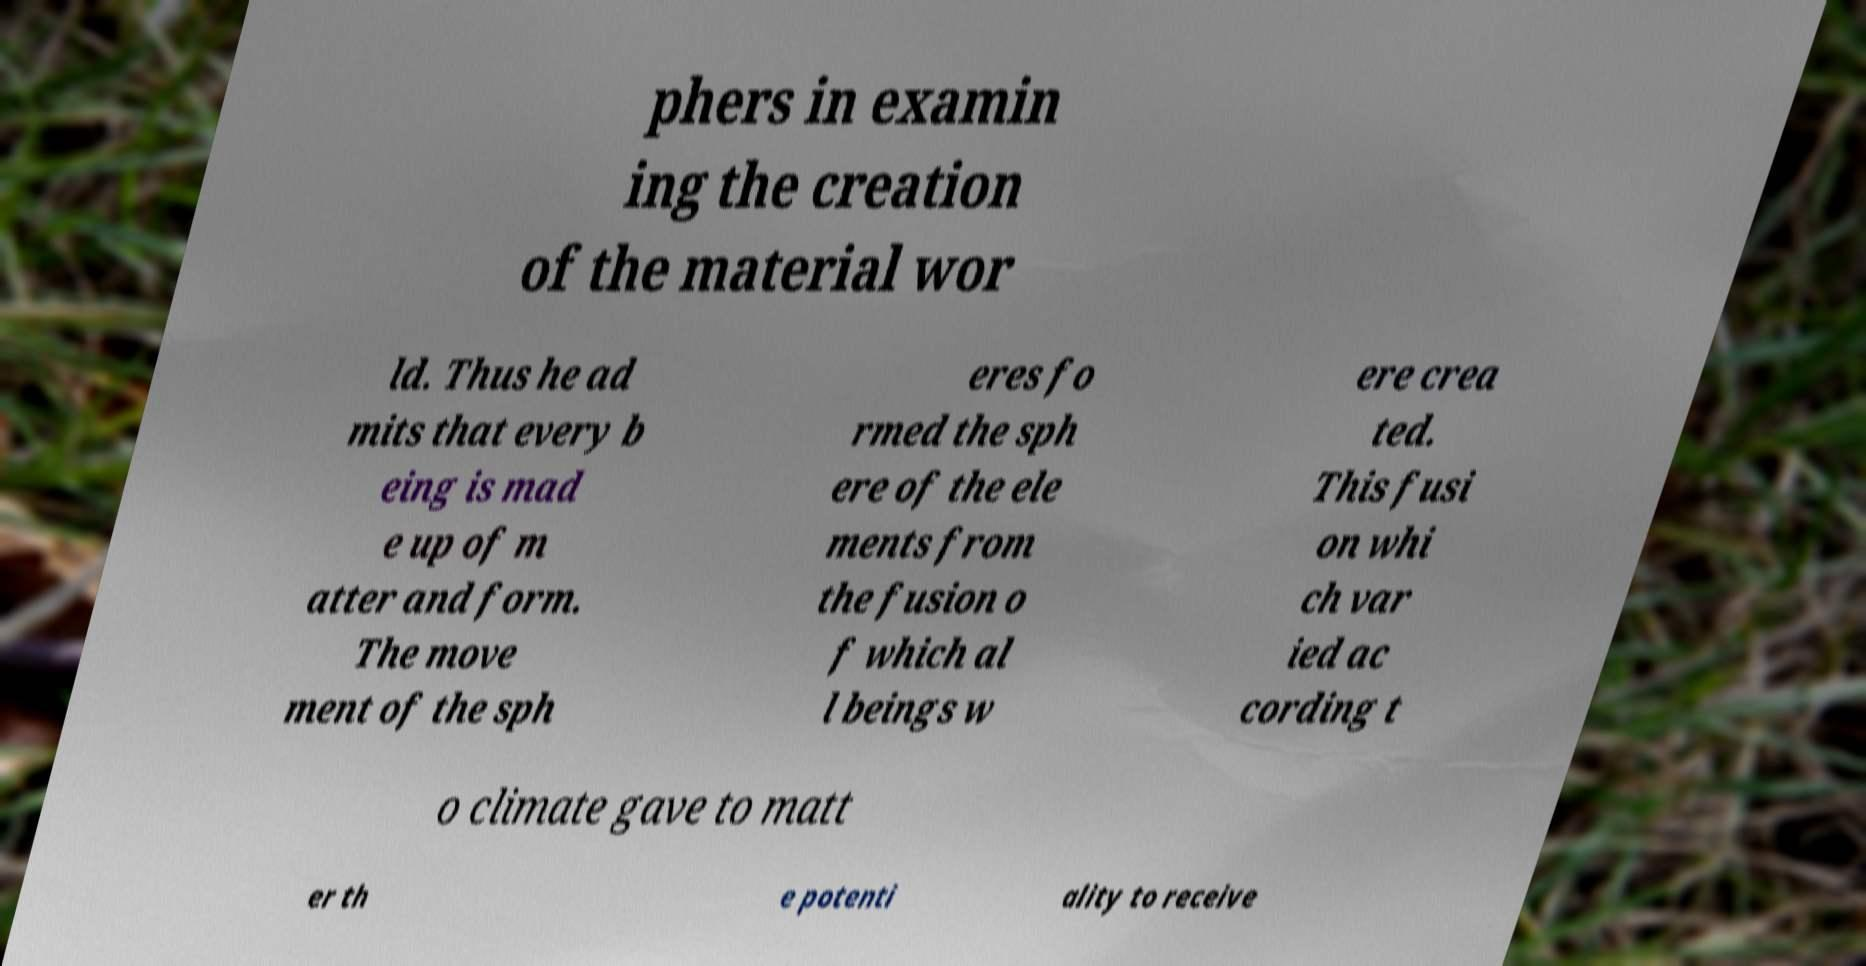What messages or text are displayed in this image? I need them in a readable, typed format. phers in examin ing the creation of the material wor ld. Thus he ad mits that every b eing is mad e up of m atter and form. The move ment of the sph eres fo rmed the sph ere of the ele ments from the fusion o f which al l beings w ere crea ted. This fusi on whi ch var ied ac cording t o climate gave to matt er th e potenti ality to receive 